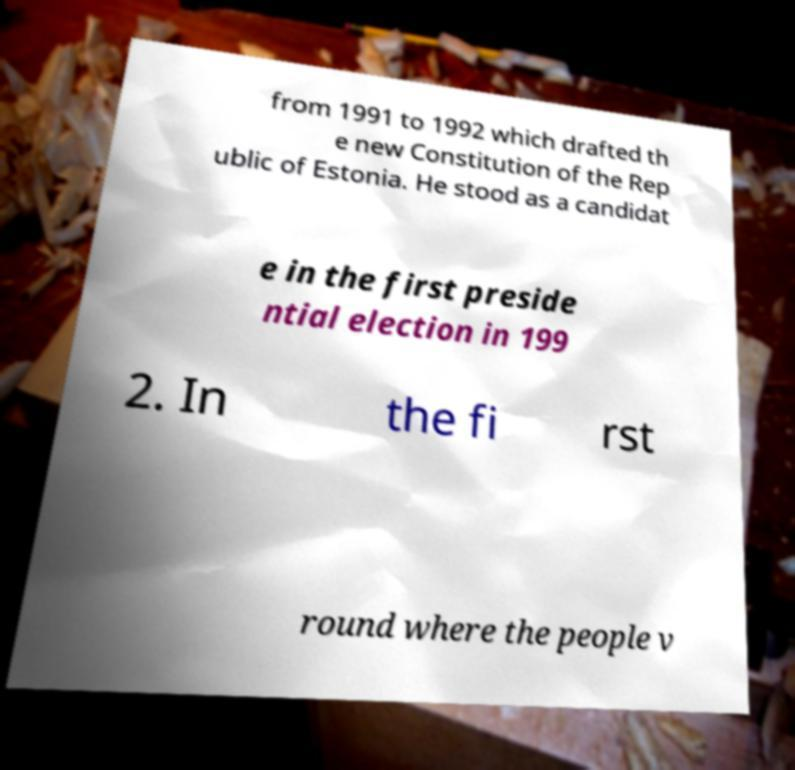There's text embedded in this image that I need extracted. Can you transcribe it verbatim? from 1991 to 1992 which drafted th e new Constitution of the Rep ublic of Estonia. He stood as a candidat e in the first preside ntial election in 199 2. In the fi rst round where the people v 